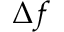<formula> <loc_0><loc_0><loc_500><loc_500>{ \Delta } f</formula> 